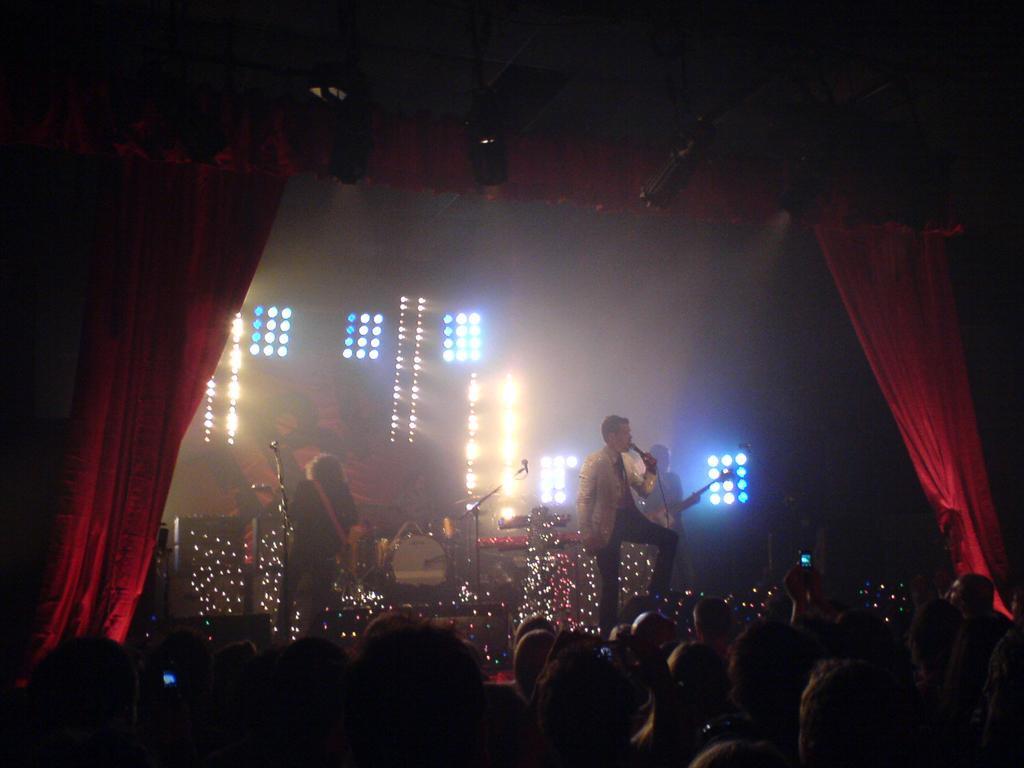Please provide a concise description of this image. In this image we can see few people playing musical instruments. A person is singing. There are many people in the image. There are many lights in the image. There is a red colored curtain in the image. 